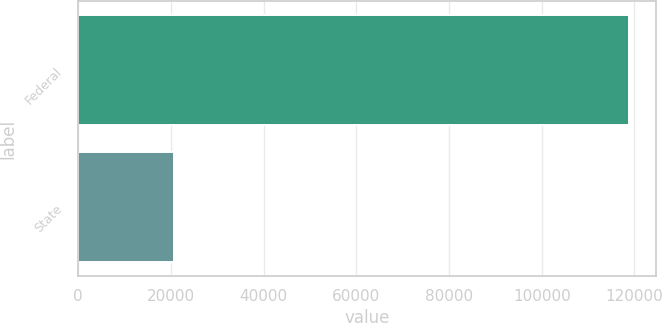Convert chart to OTSL. <chart><loc_0><loc_0><loc_500><loc_500><bar_chart><fcel>Federal<fcel>State<nl><fcel>118764<fcel>20595<nl></chart> 